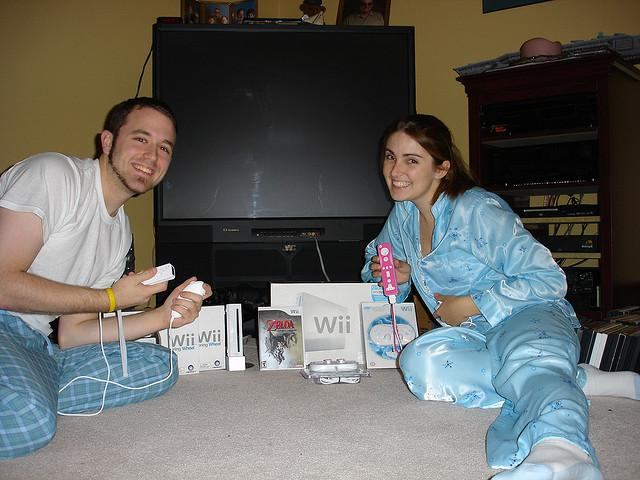Who is the main male character in that video game? zelda 